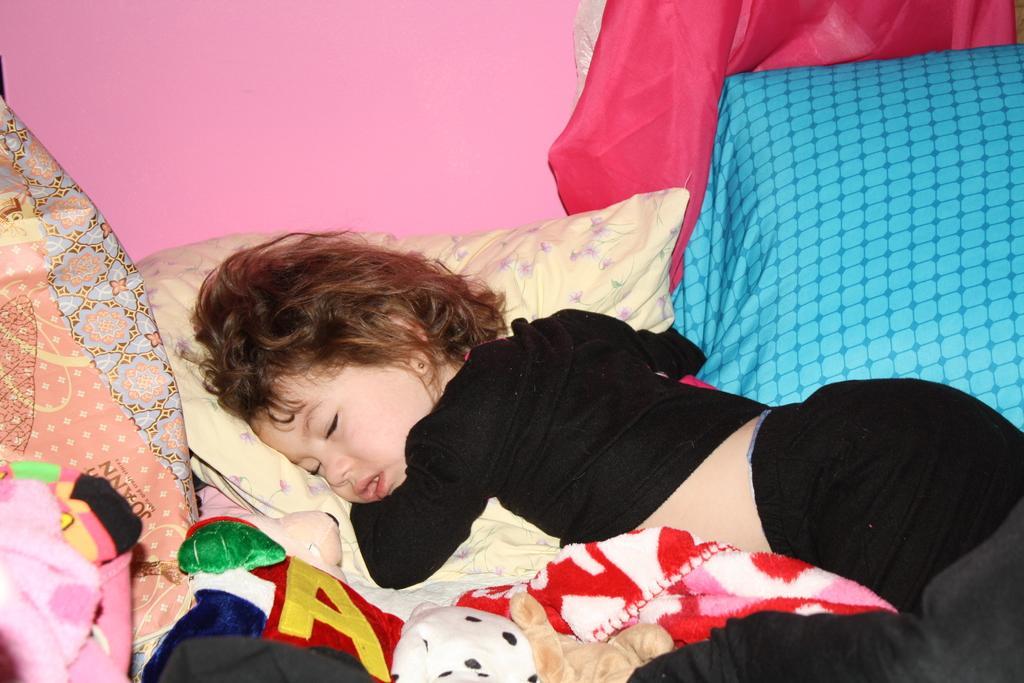Can you describe this image briefly? In this image we can see a kid sleeping on the bed and there are pillows on the bed. In the background there is a wall. At the bottom there is blanket. 